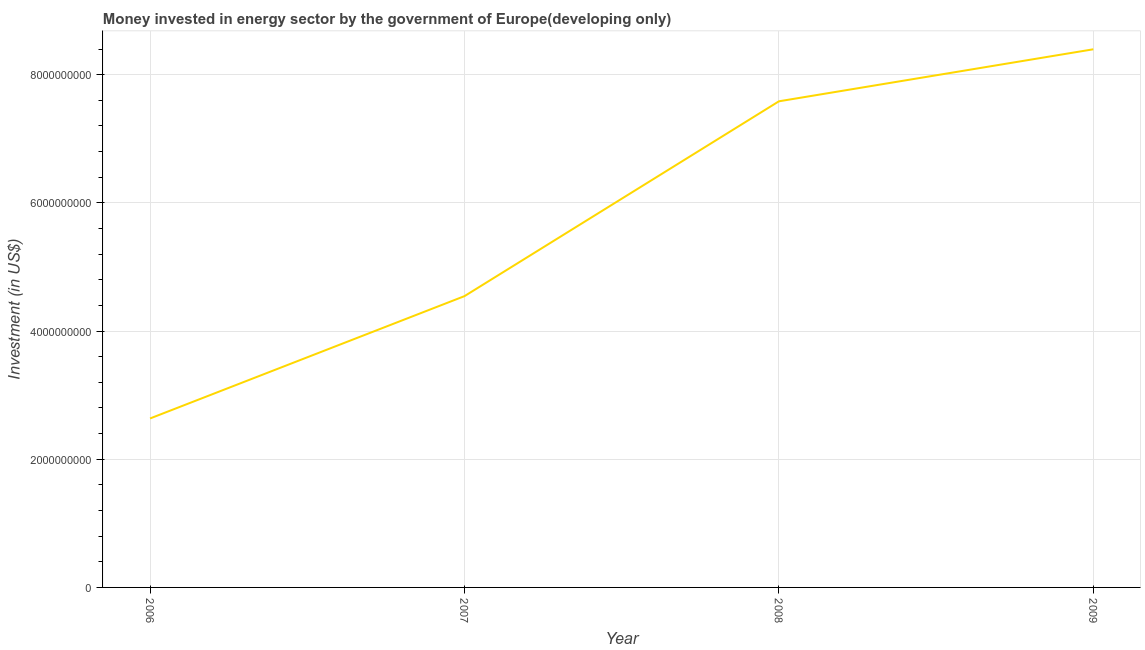What is the investment in energy in 2009?
Offer a terse response. 8.40e+09. Across all years, what is the maximum investment in energy?
Provide a succinct answer. 8.40e+09. Across all years, what is the minimum investment in energy?
Ensure brevity in your answer.  2.64e+09. In which year was the investment in energy minimum?
Keep it short and to the point. 2006. What is the sum of the investment in energy?
Make the answer very short. 2.32e+1. What is the difference between the investment in energy in 2007 and 2008?
Give a very brief answer. -3.04e+09. What is the average investment in energy per year?
Provide a succinct answer. 5.79e+09. What is the median investment in energy?
Give a very brief answer. 6.07e+09. In how many years, is the investment in energy greater than 3200000000 US$?
Offer a very short reply. 3. Do a majority of the years between 2006 and 2008 (inclusive) have investment in energy greater than 800000000 US$?
Keep it short and to the point. Yes. What is the ratio of the investment in energy in 2008 to that in 2009?
Ensure brevity in your answer.  0.9. Is the difference between the investment in energy in 2007 and 2008 greater than the difference between any two years?
Keep it short and to the point. No. What is the difference between the highest and the second highest investment in energy?
Provide a short and direct response. 8.12e+08. Is the sum of the investment in energy in 2006 and 2009 greater than the maximum investment in energy across all years?
Give a very brief answer. Yes. What is the difference between the highest and the lowest investment in energy?
Your response must be concise. 5.76e+09. Does the investment in energy monotonically increase over the years?
Provide a succinct answer. Yes. What is the difference between two consecutive major ticks on the Y-axis?
Give a very brief answer. 2.00e+09. Are the values on the major ticks of Y-axis written in scientific E-notation?
Your response must be concise. No. What is the title of the graph?
Offer a very short reply. Money invested in energy sector by the government of Europe(developing only). What is the label or title of the Y-axis?
Offer a very short reply. Investment (in US$). What is the Investment (in US$) of 2006?
Your response must be concise. 2.64e+09. What is the Investment (in US$) of 2007?
Your answer should be compact. 4.55e+09. What is the Investment (in US$) of 2008?
Your response must be concise. 7.59e+09. What is the Investment (in US$) of 2009?
Provide a short and direct response. 8.40e+09. What is the difference between the Investment (in US$) in 2006 and 2007?
Provide a succinct answer. -1.91e+09. What is the difference between the Investment (in US$) in 2006 and 2008?
Make the answer very short. -4.95e+09. What is the difference between the Investment (in US$) in 2006 and 2009?
Ensure brevity in your answer.  -5.76e+09. What is the difference between the Investment (in US$) in 2007 and 2008?
Offer a very short reply. -3.04e+09. What is the difference between the Investment (in US$) in 2007 and 2009?
Your response must be concise. -3.85e+09. What is the difference between the Investment (in US$) in 2008 and 2009?
Offer a terse response. -8.12e+08. What is the ratio of the Investment (in US$) in 2006 to that in 2007?
Your response must be concise. 0.58. What is the ratio of the Investment (in US$) in 2006 to that in 2008?
Your answer should be very brief. 0.35. What is the ratio of the Investment (in US$) in 2006 to that in 2009?
Your answer should be compact. 0.31. What is the ratio of the Investment (in US$) in 2007 to that in 2008?
Keep it short and to the point. 0.6. What is the ratio of the Investment (in US$) in 2007 to that in 2009?
Give a very brief answer. 0.54. What is the ratio of the Investment (in US$) in 2008 to that in 2009?
Make the answer very short. 0.9. 